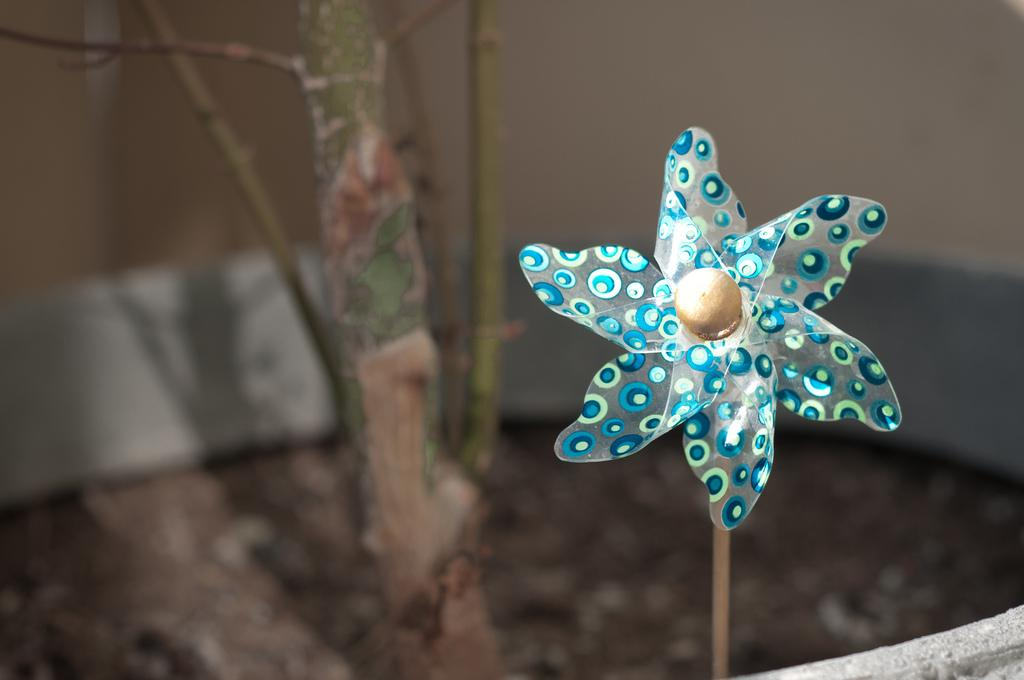What is the main object in the image? There is a colorful wind blower in the image. Can you describe the wind blower in more detail? The wind blower has colorful blades that spin when powered. What else can be seen in the image besides the wind blower? There is a tree stem in the image. Who is giving the person in the image a surprise haircut? There is no person in the image receiving a haircut, nor is there anyone giving a haircut. The image only features a colorful wind blower and a tree stem. 